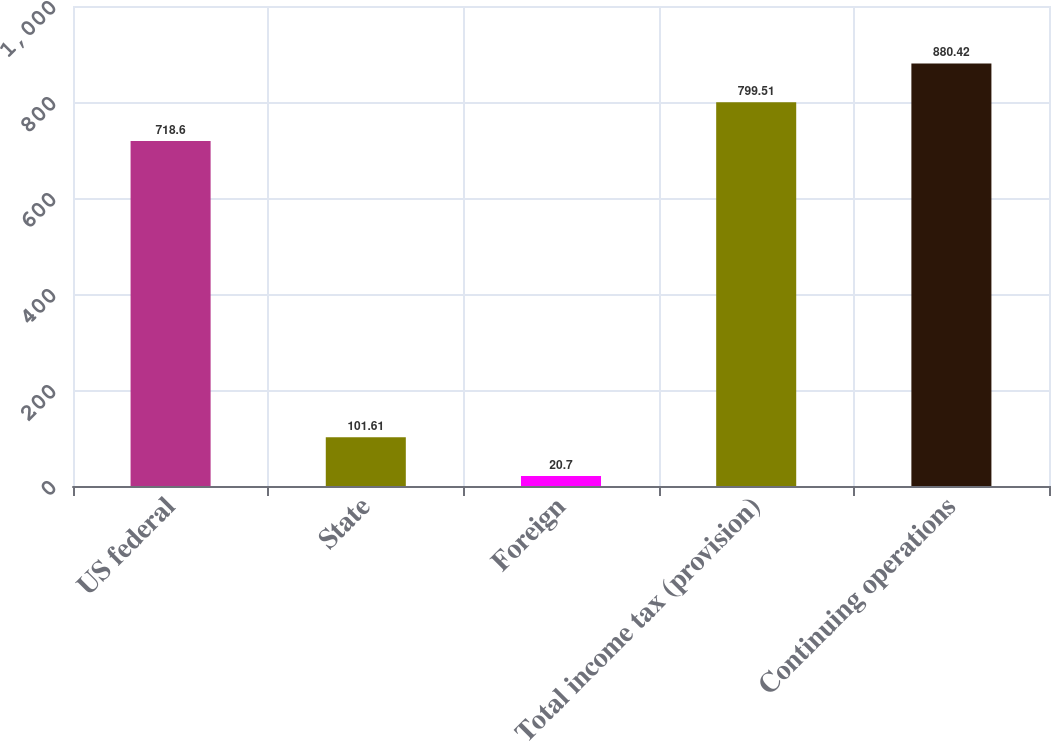Convert chart to OTSL. <chart><loc_0><loc_0><loc_500><loc_500><bar_chart><fcel>US federal<fcel>State<fcel>Foreign<fcel>Total income tax (provision)<fcel>Continuing operations<nl><fcel>718.6<fcel>101.61<fcel>20.7<fcel>799.51<fcel>880.42<nl></chart> 